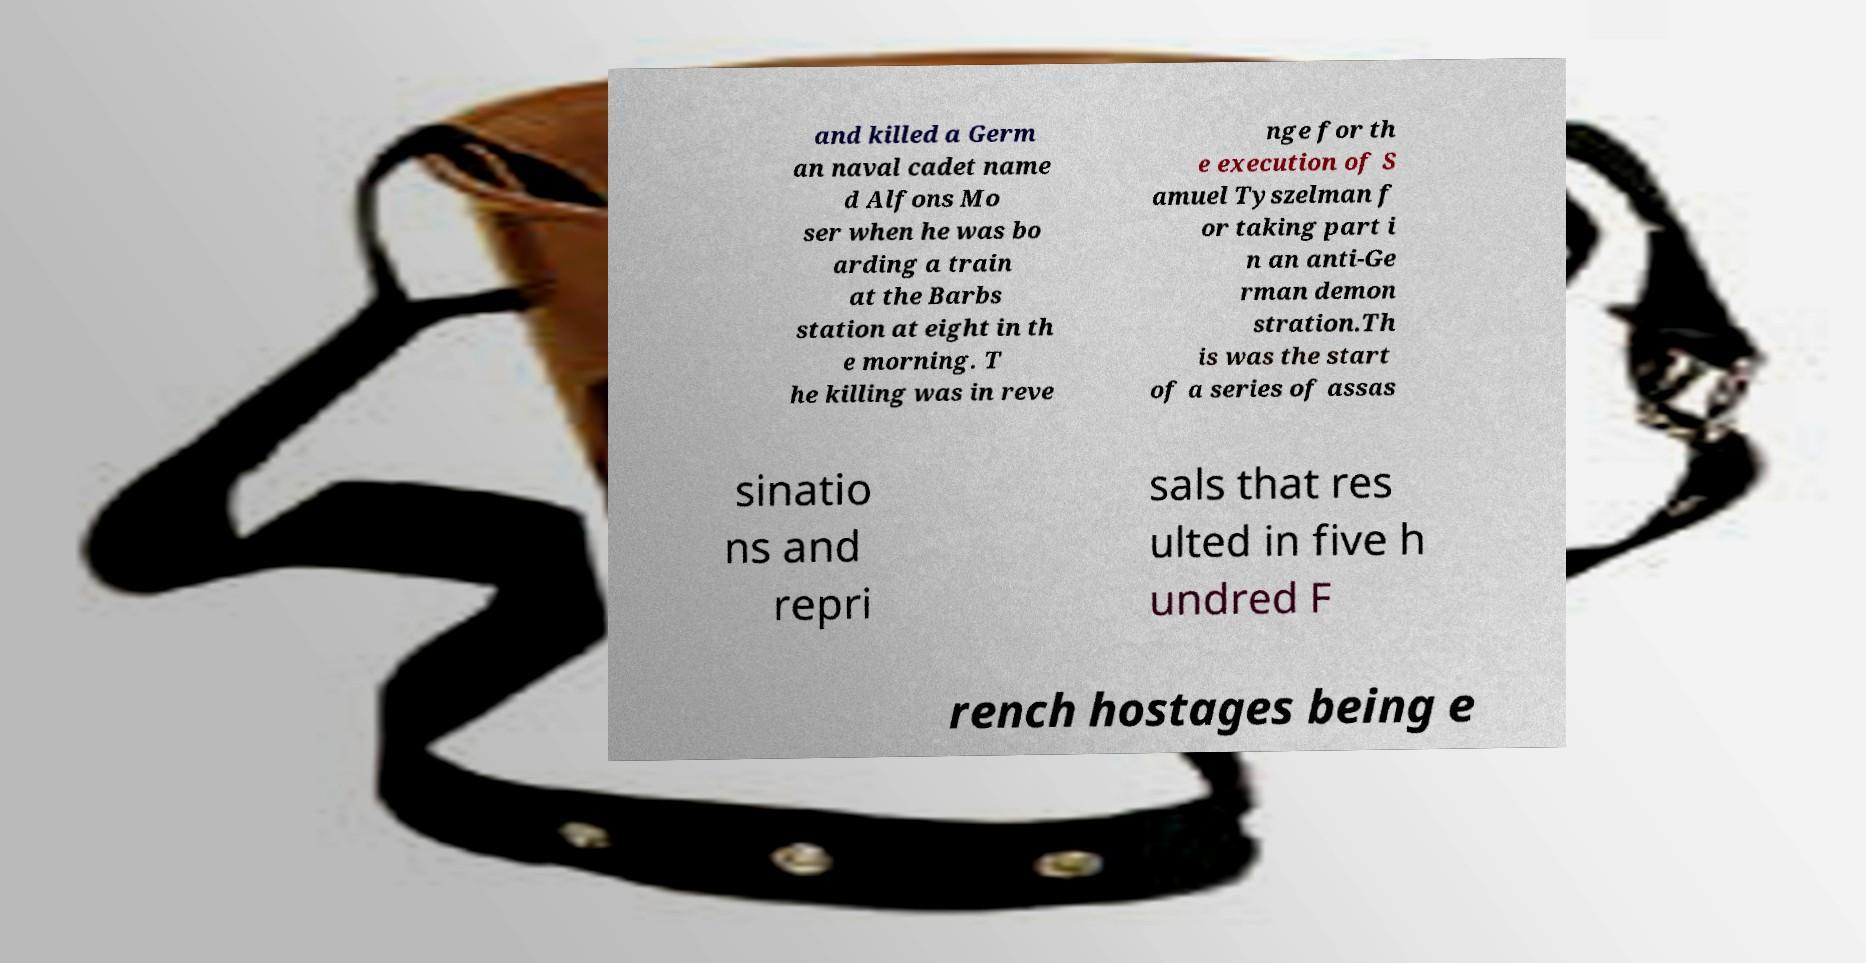What messages or text are displayed in this image? I need them in a readable, typed format. and killed a Germ an naval cadet name d Alfons Mo ser when he was bo arding a train at the Barbs station at eight in th e morning. T he killing was in reve nge for th e execution of S amuel Tyszelman f or taking part i n an anti-Ge rman demon stration.Th is was the start of a series of assas sinatio ns and repri sals that res ulted in five h undred F rench hostages being e 